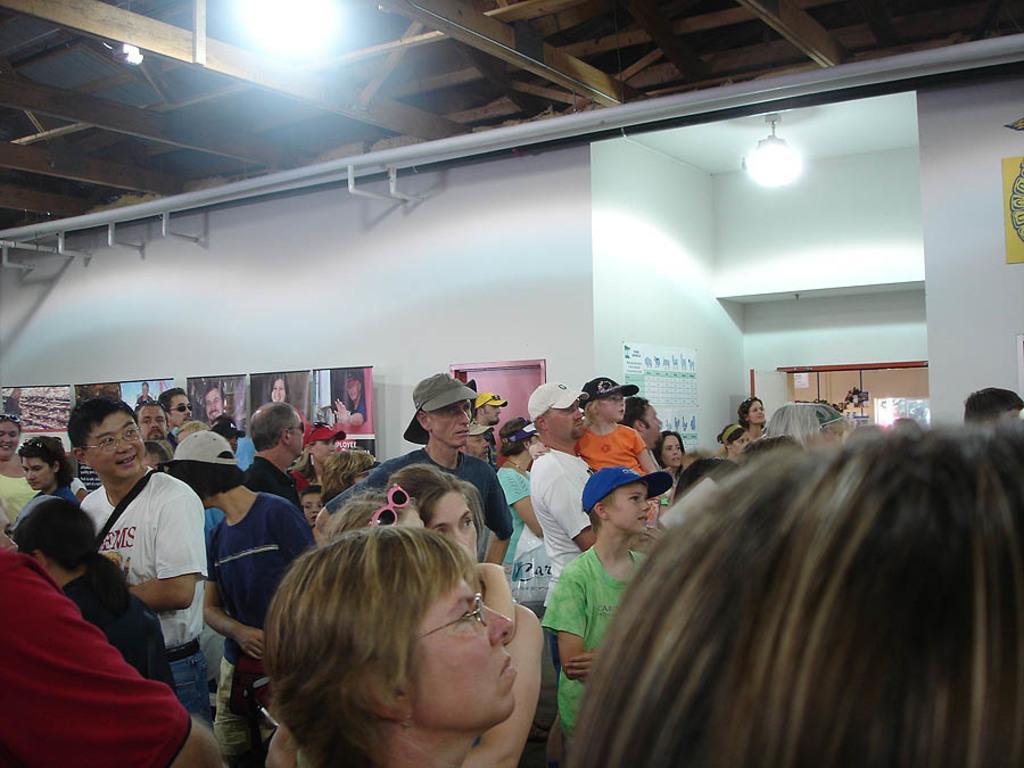Could you give a brief overview of what you see in this image? As we can see in the image there is a white color wall, lights, banners and few people here and there. 